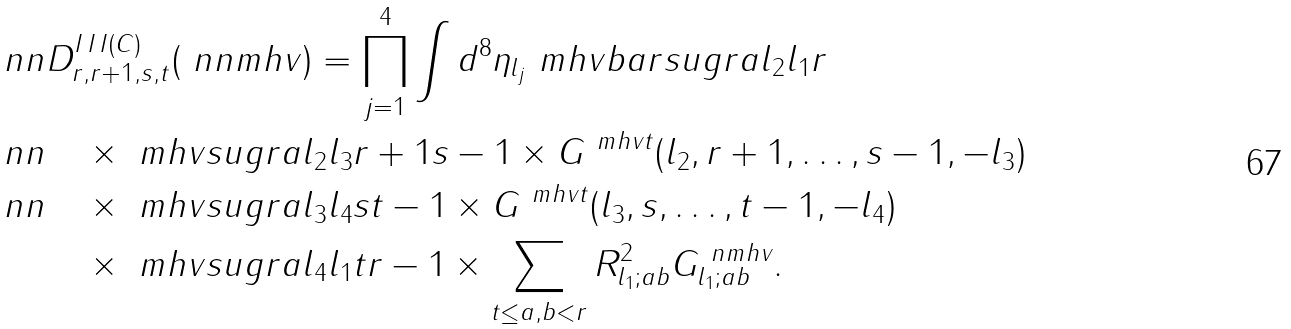<formula> <loc_0><loc_0><loc_500><loc_500>\ n n & D _ { r , r + 1 , s , t } ^ { I \, I \, I ( C ) } ( \ n n m h v ) = \prod _ { j = 1 } ^ { 4 } \int d ^ { 8 } \eta _ { l _ { j } } \ m h v b a r s u g r a { l _ { 2 } } { l _ { 1 } } { r } \\ \ n n & \quad \times \ m h v s u g r a { l _ { 2 } } { l _ { 3 } } { r + 1 } { s - 1 } \times G ^ { \ m h v t } ( l _ { 2 } , r + 1 , \dots , s - 1 , - l _ { 3 } ) \\ \ n n & \quad \times \ m h v s u g r a { l _ { 3 } } { l _ { 4 } } { s } { t - 1 } \times G ^ { \ m h v t } ( l _ { 3 } , s , \dots , t - 1 , - l _ { 4 } ) \\ & \quad \times \ m h v s u g r a { l _ { 4 } } { l _ { 1 } } { t } { r - 1 } \times \sum _ { t \leq a , b < r } R _ { l _ { 1 } ; a b } ^ { 2 } G ^ { \ n m h v } _ { l _ { 1 } ; a b } .</formula> 